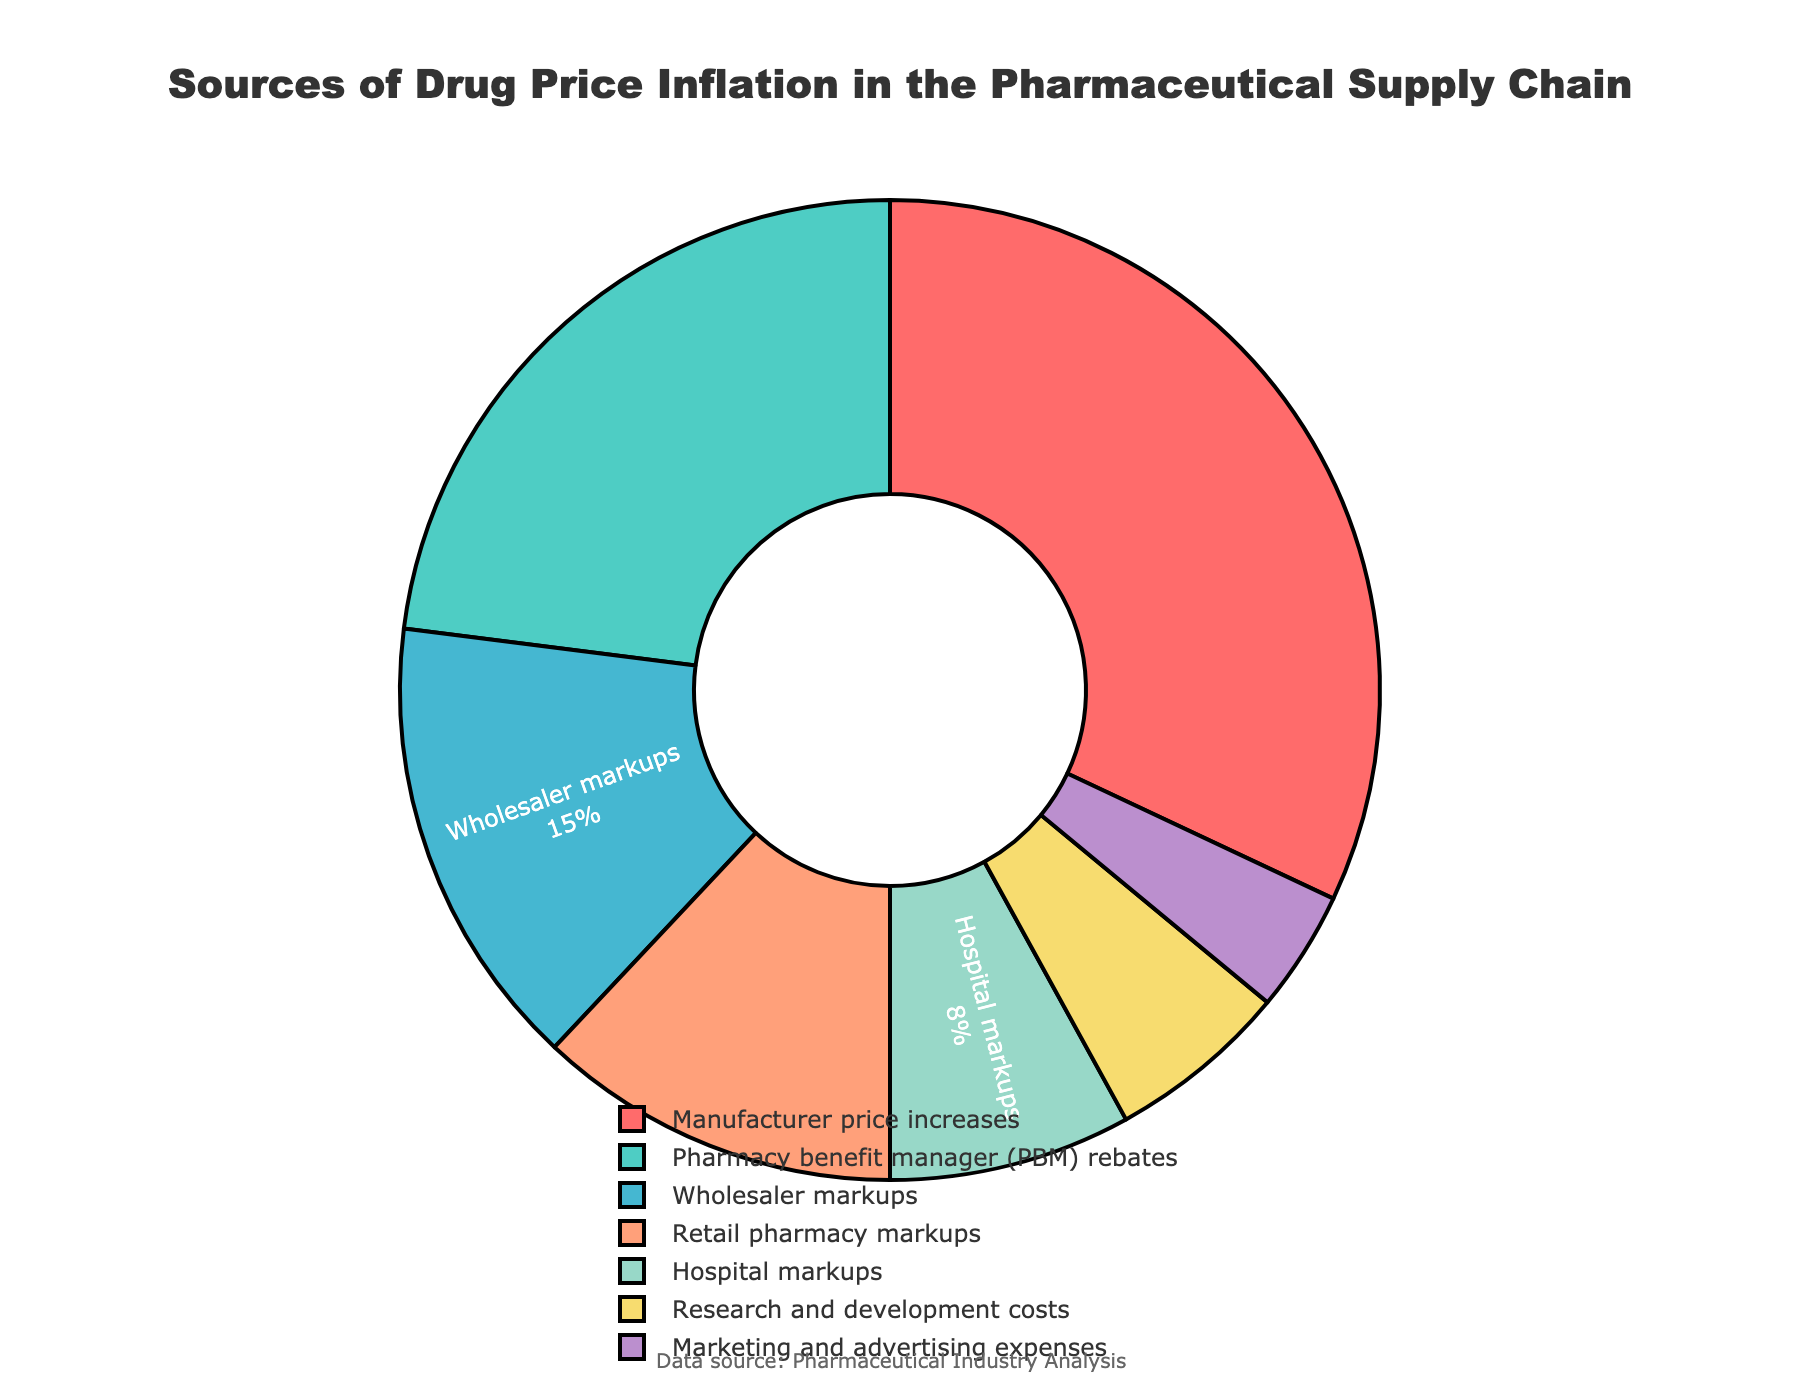What's the category with the highest percentage? By directly looking at the sectors in the pie chart and the corresponding labels, "Manufacturer price increases" stands out as the largest.
Answer: Manufacturer price increases Which two categories together make up more than 50% of the total? Summing the percentages of the top two categories: "Manufacturer price increases" (32%) and "Pharmacy benefit manager (PBM) rebates" (23%) gives us 32% + 23% = 55%, which is more than 50%.
Answer: Manufacturer price increases and Pharmacy benefit manager (PBM) rebates Which category has the smallest contribution, and what is its percentage? By checking the smallest sector in the pie chart, "Marketing and advertising expenses" is identified with a percentage of 4%.
Answer: Marketing and advertising expenses, 4% How much more is the percentage of "Manufacturer price increases" compared to "Research and development costs"? The percentage for "Manufacturer price increases" is 32% and for "Research and development costs" is 6%. The difference is 32% - 6% = 26%.
Answer: 26% If we combine "Retail pharmacy markups" and "Hospital markups," what is their total percentage? Summing the percentages of "Retail pharmacy markups" (12%) and "Hospital markups" (8%) gives 12% + 8% = 20%.
Answer: 20% What is the total percentage of all categories shown? Summing all the given percentages: 32 + 23 + 15 + 12 + 8 + 6 + 4, which equals 100%.
Answer: 100% Does "Wholesaler markups" have a higher percentage than "Hospital markups"? Comparing the two, "Wholesaler markups" (15%) is higher than "Hospital markups" (8%).
Answer: Yes What are the visual colors of the largest and smallest categories, and how do they appear? The largest category "Manufacturer price increases" is visually represented in red, and the smallest category "Marketing and advertising expenses" appears in purple.
Answer: Red and purple What percentage does "Pharmacy benefit manager (PBM) rebates" represent, and is it more than double of "Marketing and advertising expenses"? "Pharmacy benefit manager (PBM) rebates" is 23%, and yes, 23% is more than twice 4% (which is the percentage for "Marketing and advertising expenses").
Answer: 23%, yes 